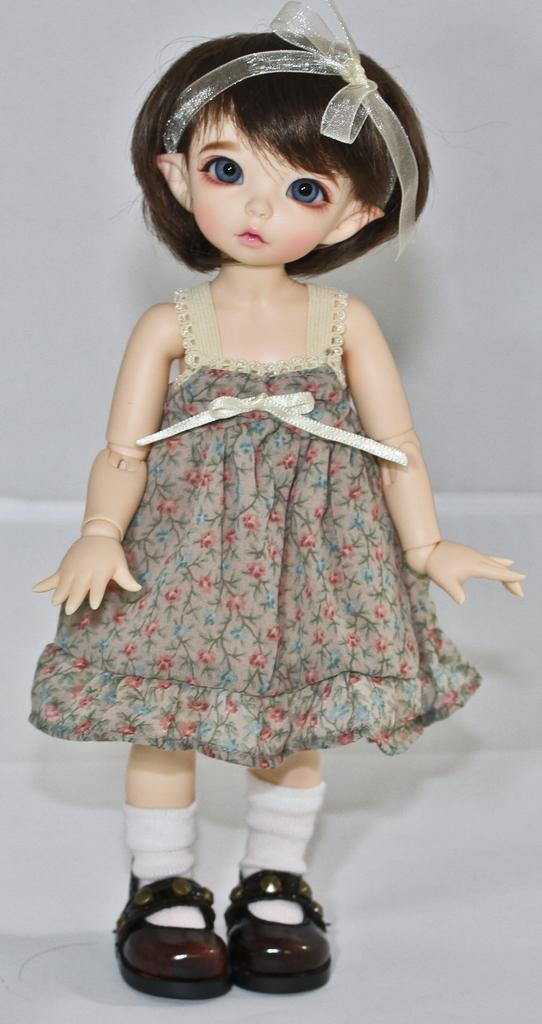What is the main subject in the center of the image? There is a doll in the center of the image. What can be seen in the background of the image? There is a white surface in the background of the image. What type of wilderness can be seen in the background of the image? There is no wilderness present in the image; it features a doll in the center and a white surface in the background. What type of growth can be observed on the doll in the image? There is no growth visible on the doll in the image, as it is an inanimate object. 